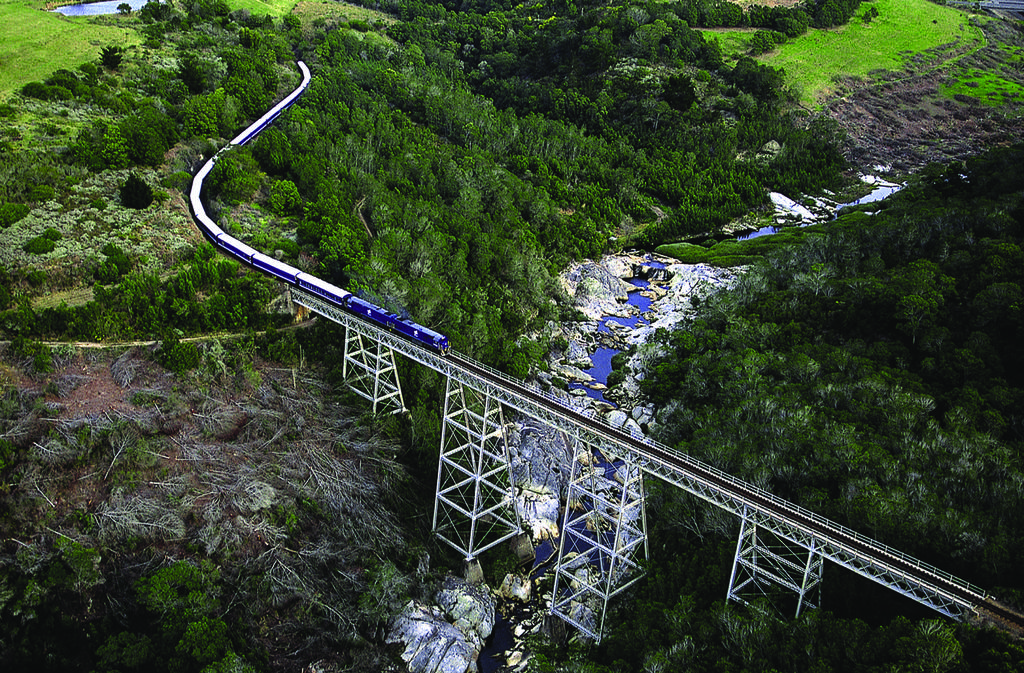What is the main structure in the center of the image? There is a bridge in the center of the image. What mode of transportation can be seen on the track in the image? There is a train on the track in the image. What type of natural environment is visible in the background of the image? There are trees, rocks, and water visible in the background of the image. What month is it in the image? The month cannot be determined from the image, as it does not contain any information about the time of year. Are there any people reading or playing chess in the image? There are no people visible in the image, and therefore no reading or chess activities can be observed. 